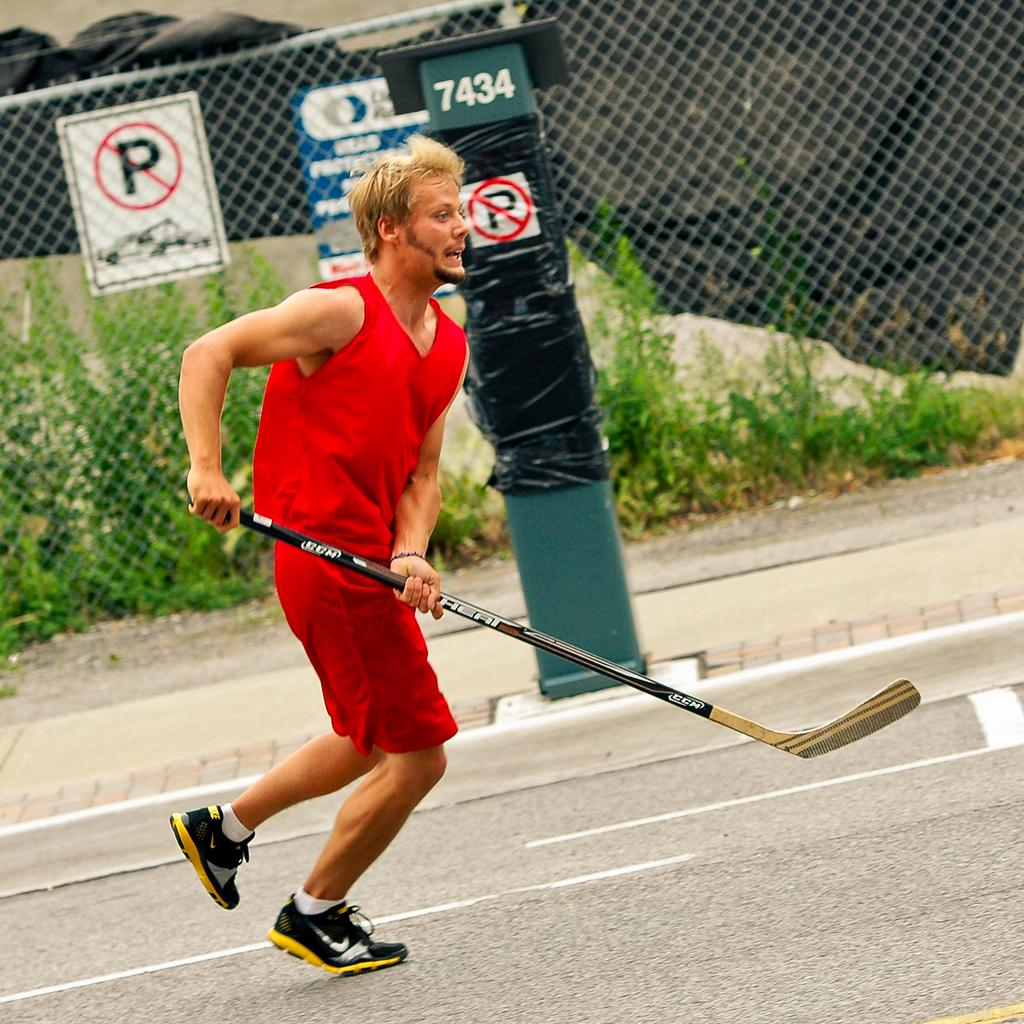Who is in the image? There is a person in the image. What is the person wearing? The person is wearing a red dress. What is the person holding? The person is holding a hockey stick. What can be seen in the background of the image? There is an object, a fence, and plants in the background of the image. What type of jewel can be seen on the person's forehead in the image? There is no jewel visible on the person's forehead in the image. 